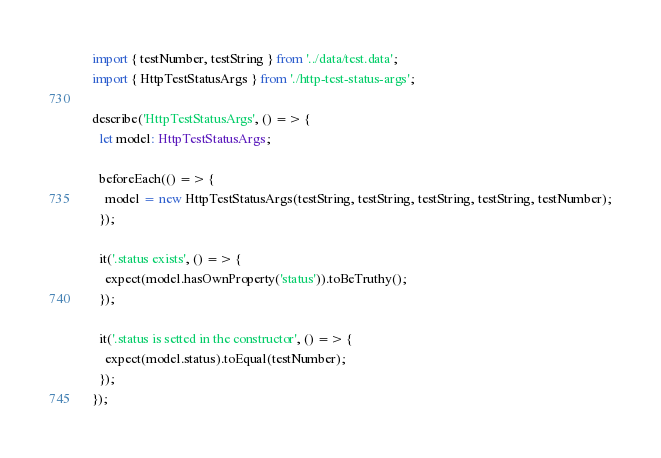<code> <loc_0><loc_0><loc_500><loc_500><_TypeScript_>import { testNumber, testString } from '../data/test.data';
import { HttpTestStatusArgs } from './http-test-status-args';

describe('HttpTestStatusArgs', () => {
  let model: HttpTestStatusArgs;

  beforeEach(() => {
    model = new HttpTestStatusArgs(testString, testString, testString, testString, testNumber);
  });

  it('.status exists', () => {
    expect(model.hasOwnProperty('status')).toBeTruthy();
  });

  it('.status is setted in the constructor', () => {
    expect(model.status).toEqual(testNumber);
  });
});
</code> 